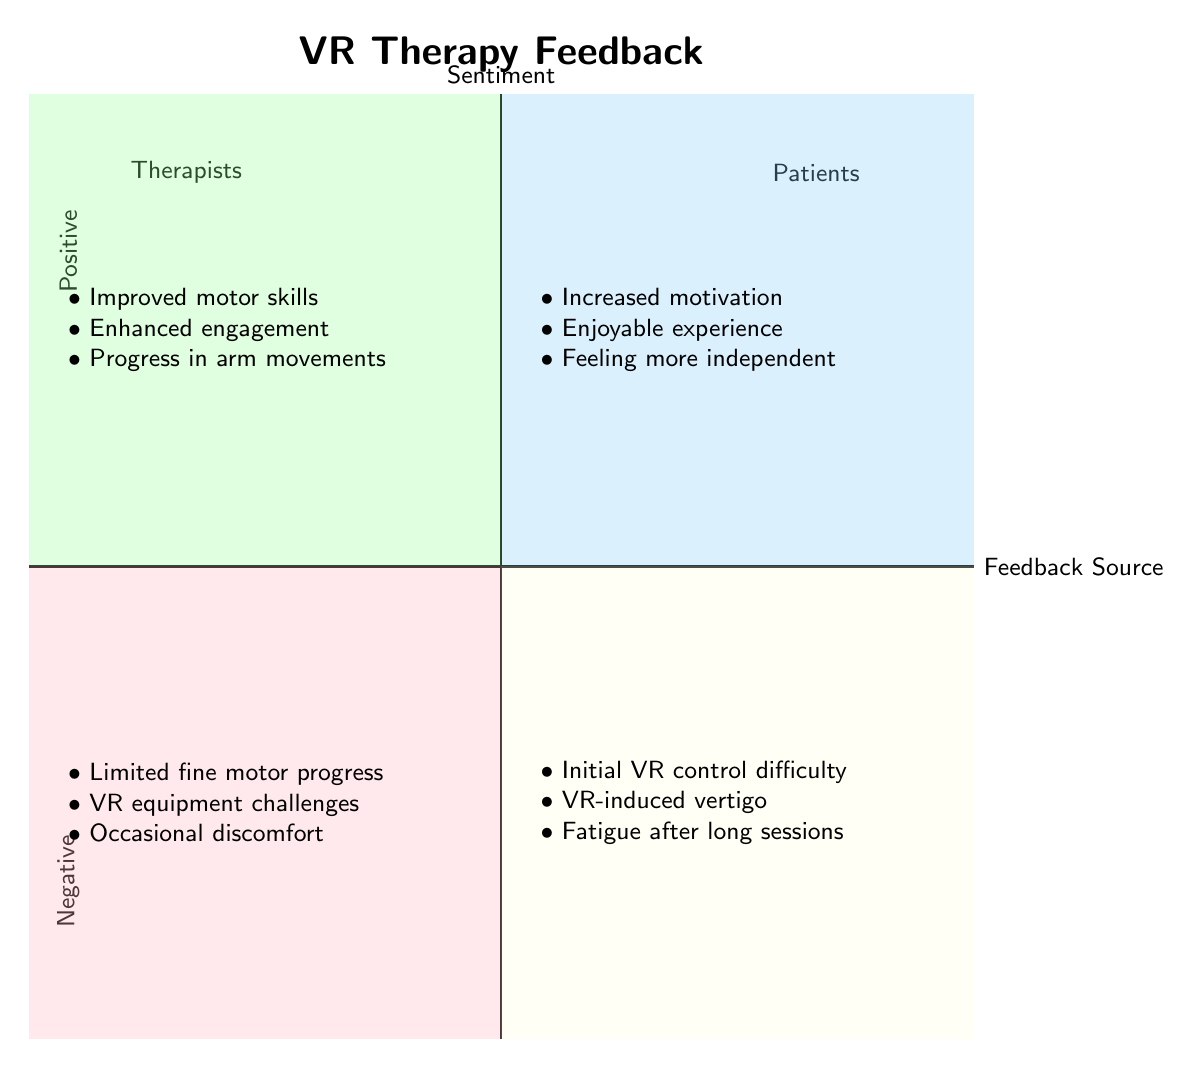What feedback did Dr. Smith provide? The diagram shows that Dr. Smith reported "Improved motor skills observed," which is placed in the positive feedback category from therapists.
Answer: Improved motor skills observed What is the overall sentiment of patient feedback? The chart illustrates that there is both positive and negative feedback from patients, but the location of the data implies mixed sentiments. The positive quadrant contains comments like "Increased motivation to practice."
Answer: Mixed How many categories of feedback are there in the diagram? The diagram consists of four distinct categories: positive feedback from therapists, negative feedback from therapists, positive feedback from patients, and negative feedback from patients. Therefore, the total count is 4.
Answer: 4 Which quadrant contains the most patient feedback? The positive feedback from patients quadrant has three specific comments, while the negative feedback from patients quadrant also contains three comments. Thus, both quadrants equally represent patient feedback.
Answer: Equal What common theme is observed in positive feedback from therapists? The positive feedback from therapists emphasizes observational improvements, such as enhanced motor skills and engagement, making the common theme focus on progress and engagement.
Answer: Progress and engagement How many negative feedback entries are attributed to therapists? In the negative feedback quadrant for therapists, there are three specific entries listed: "Limited fine motor progress," "Challenges with VR equipment," and "Occasional discomfort." Thus, the total is three.
Answer: 3 Which patient mentioned enjoying the VR experience? According to the diagram, Jane Roe is the patient who specifically noted an "enjoyable and immersive experience," placing her feedback in the positive category for patients.
Answer: Jane Roe What equipment challenges are noted in the negative feedback from therapists? The feedback states that there are "Challenges with VR equipment," which indicates issues faced by therapists while utilizing VR for therapy, classified under negative feedback.
Answer: Challenges with VR equipment How does the feedback from therapists compare to that from patients? The diagram indicates that both therapists and patients provide feedback across positive and negative sentiments; however, therapists primarily focus on the technical aspects of progress, whereas patients focus on personal experience and motivation.
Answer: Different focus areas 